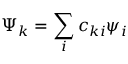<formula> <loc_0><loc_0><loc_500><loc_500>\Psi _ { k } = \sum _ { i } c _ { k i } \psi _ { i }</formula> 